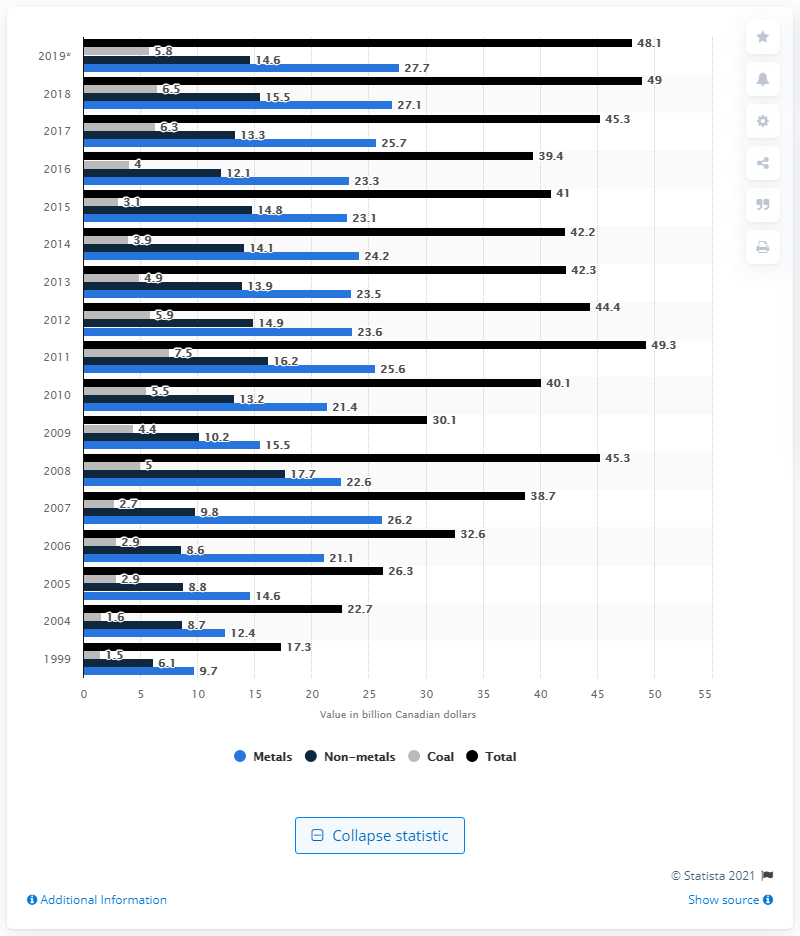Mention a couple of crucial points in this snapshot. In 2019, the value of metal production in Canada was 27.7 billion Canadian dollars. In 2019, the value of non-metals in Canada was CAD 14.6 billion. 